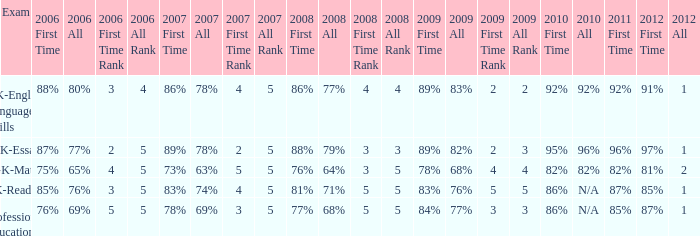What is the percentage for all in 2008 when all in 2007 was 69%? 68%. 